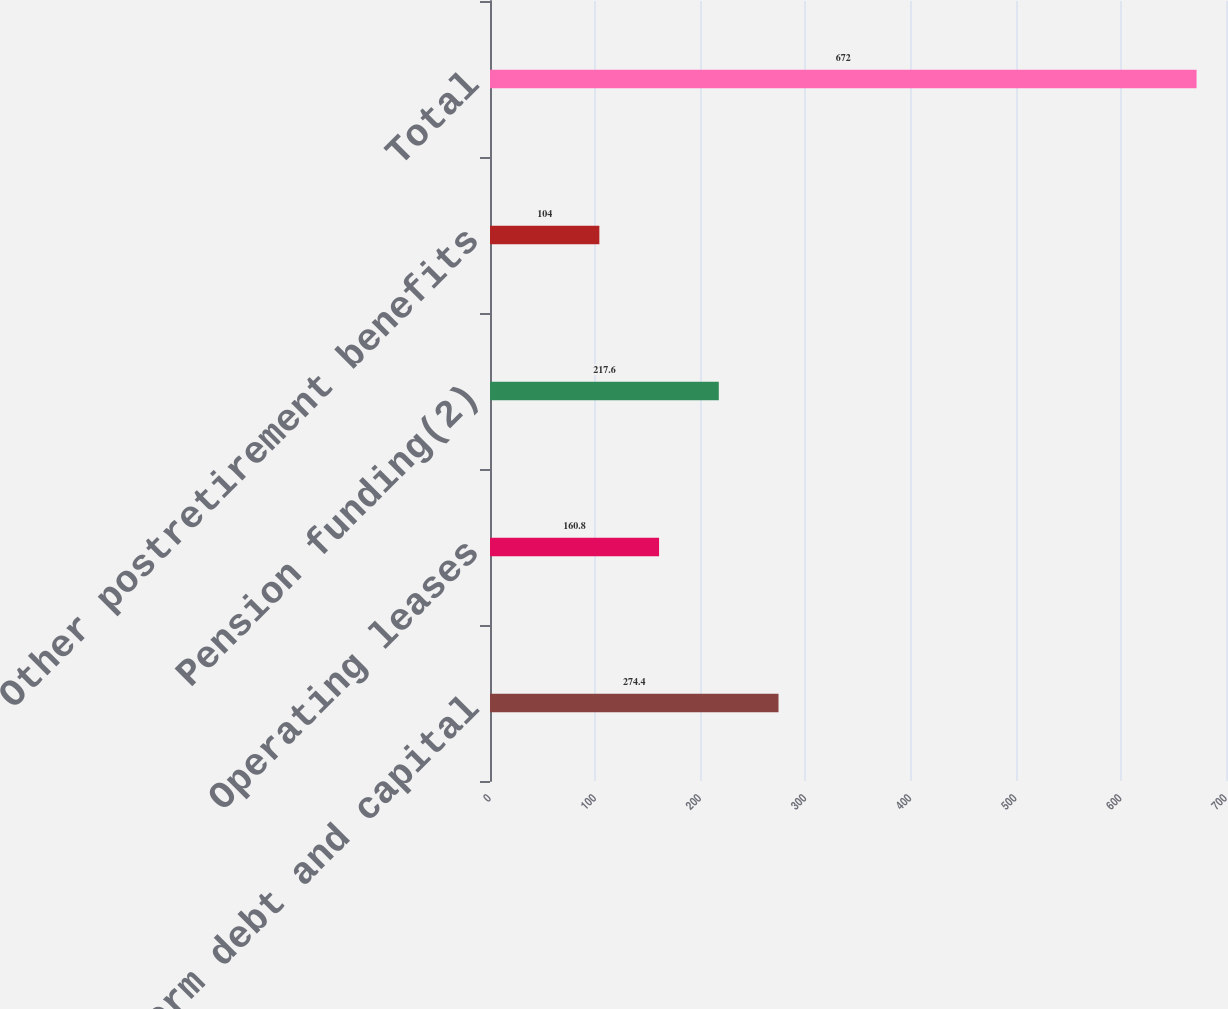<chart> <loc_0><loc_0><loc_500><loc_500><bar_chart><fcel>Long-term debt and capital<fcel>Operating leases<fcel>Pension funding(2)<fcel>Other postretirement benefits<fcel>Total<nl><fcel>274.4<fcel>160.8<fcel>217.6<fcel>104<fcel>672<nl></chart> 